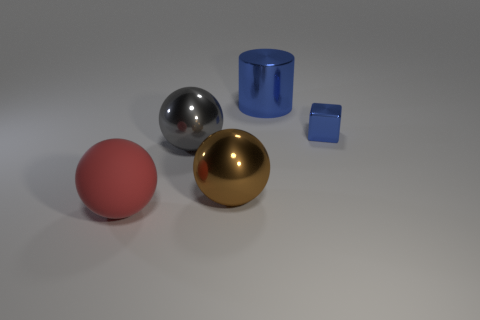Subtract all large matte spheres. How many spheres are left? 2 Subtract 1 spheres. How many spheres are left? 2 Add 5 tiny things. How many objects exist? 10 Subtract all cylinders. How many objects are left? 4 Subtract all gray balls. Subtract all tiny brown spheres. How many objects are left? 4 Add 4 tiny blue shiny objects. How many tiny blue shiny objects are left? 5 Add 3 big purple cylinders. How many big purple cylinders exist? 3 Subtract 0 blue balls. How many objects are left? 5 